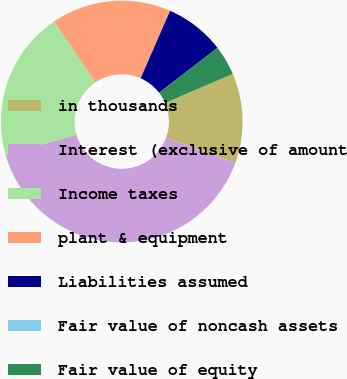<chart> <loc_0><loc_0><loc_500><loc_500><pie_chart><fcel>in thousands<fcel>Interest (exclusive of amount<fcel>Income taxes<fcel>plant & equipment<fcel>Liabilities assumed<fcel>Fair value of noncash assets<fcel>Fair value of equity<nl><fcel>12.0%<fcel>40.0%<fcel>20.0%<fcel>16.0%<fcel>8.0%<fcel>0.0%<fcel>4.0%<nl></chart> 